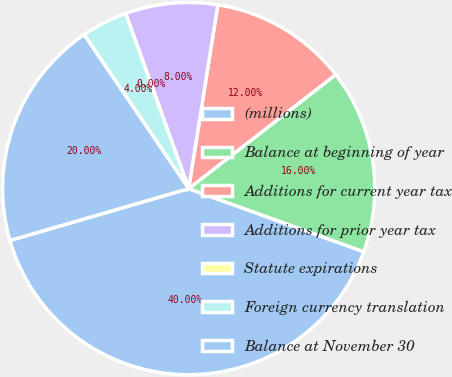<chart> <loc_0><loc_0><loc_500><loc_500><pie_chart><fcel>(millions)<fcel>Balance at beginning of year<fcel>Additions for current year tax<fcel>Additions for prior year tax<fcel>Statute expirations<fcel>Foreign currency translation<fcel>Balance at November 30<nl><fcel>40.0%<fcel>16.0%<fcel>12.0%<fcel>8.0%<fcel>0.0%<fcel>4.0%<fcel>20.0%<nl></chart> 